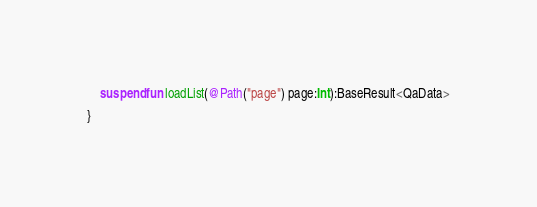<code> <loc_0><loc_0><loc_500><loc_500><_Kotlin_>    suspend fun loadList(@Path("page") page:Int):BaseResult<QaData>

}</code> 